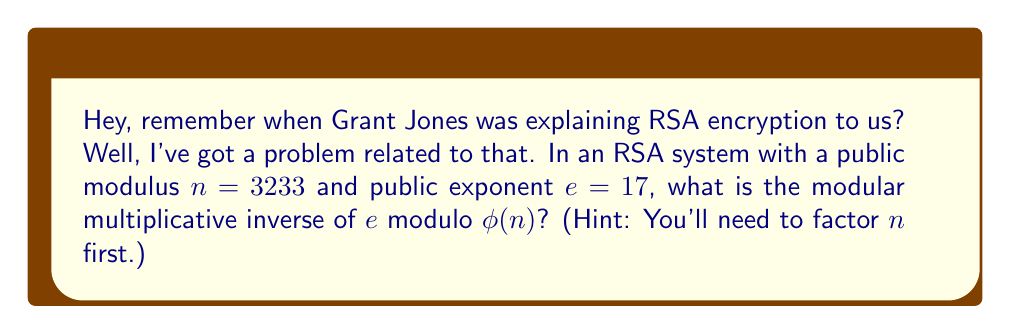Can you solve this math problem? Let's approach this step-by-step:

1) First, we need to factor $n = 3233$. 
   $3233 = 61 \times 53$ (both prime factors)

2) Now we can calculate $\phi(n)$:
   $\phi(n) = (p-1)(q-1) = (61-1)(53-1) = 60 \times 52 = 3120$

3) We need to find $d$ such that $ed \equiv 1 \pmod{\phi(n)}$
   In other words, find $d$ such that $17d \equiv 1 \pmod{3120}$

4) We can use the extended Euclidean algorithm to find $d$:

   $3120 = 183 \times 17 + 9$
   $17 = 1 \times 9 + 8$
   $9 = 1 \times 8 + 1$
   $8 = 8 \times 1 + 0$

5) Working backwards:
   $1 = 9 - 1 \times 8$
   $1 = 9 - 1 \times (17 - 1 \times 9) = 2 \times 9 - 1 \times 17$
   $1 = 2 \times (3120 - 183 \times 17) - 1 \times 17$
   $1 = 2 \times 3120 - 367 \times 17$

6) Therefore, $-367 \times 17 \equiv 1 \pmod{3120}$

7) We need a positive number, so we add $3120$ to $-367$ until we get a positive number:
   $-367 + 3120 = 2753$

8) Verify: $17 \times 2753 = 46801 \equiv 1 \pmod{3120}$

Therefore, $d = 2753$ is the modular multiplicative inverse of $17$ modulo $3120$.
Answer: $2753$ 